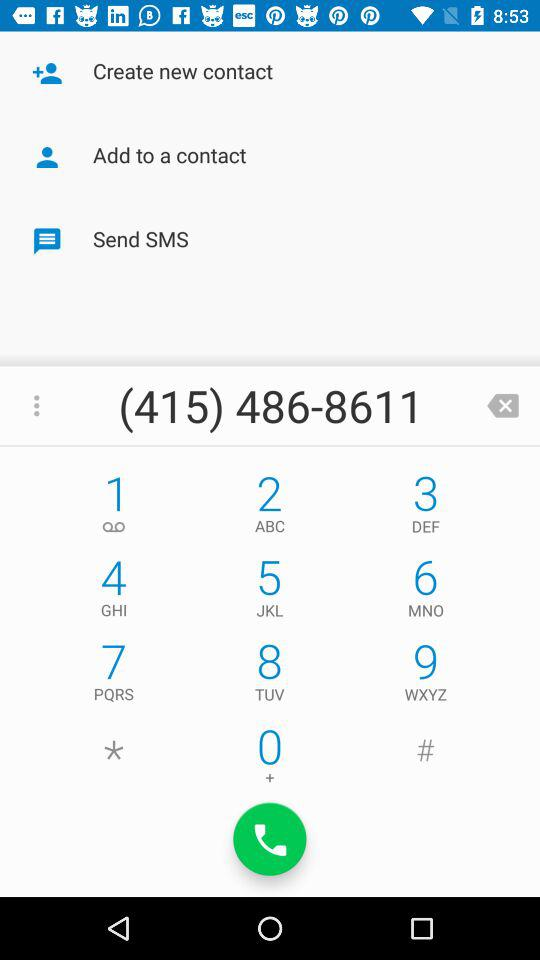What is the contact number? The contact number is (415) 486-8611. 